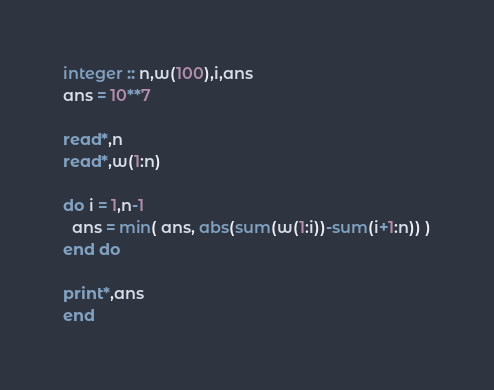Convert code to text. <code><loc_0><loc_0><loc_500><loc_500><_FORTRAN_>integer :: n,w(100),i,ans
ans = 10**7

read*,n
read*,w(1:n)

do i = 1,n-1
  ans = min( ans, abs(sum(w(1:i))-sum(i+1:n)) )
end do

print*,ans
end</code> 